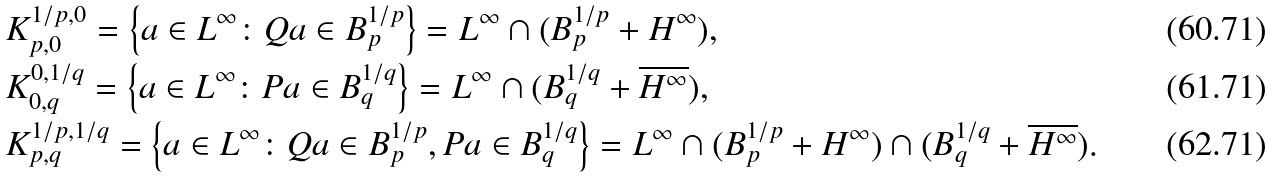Convert formula to latex. <formula><loc_0><loc_0><loc_500><loc_500>& K _ { p , 0 } ^ { 1 / p , 0 } = \left \{ a \in L ^ { \infty } \colon Q a \in B _ { p } ^ { 1 / p } \right \} = L ^ { \infty } \cap ( B _ { p } ^ { 1 / p } + H ^ { \infty } ) , \\ & K _ { 0 , q } ^ { 0 , 1 / q } = \left \{ a \in L ^ { \infty } \colon P a \in B _ { q } ^ { 1 / q } \right \} = L ^ { \infty } \cap ( B _ { q } ^ { 1 / q } + \overline { H ^ { \infty } } ) , \\ & K _ { p , q } ^ { 1 / p , 1 / q } = \left \{ a \in L ^ { \infty } \colon Q a \in B _ { p } ^ { 1 / p } , P a \in B _ { q } ^ { 1 / q } \right \} = L ^ { \infty } \cap ( B _ { p } ^ { 1 / p } + H ^ { \infty } ) \cap ( B _ { q } ^ { 1 / q } + \overline { H ^ { \infty } } ) .</formula> 